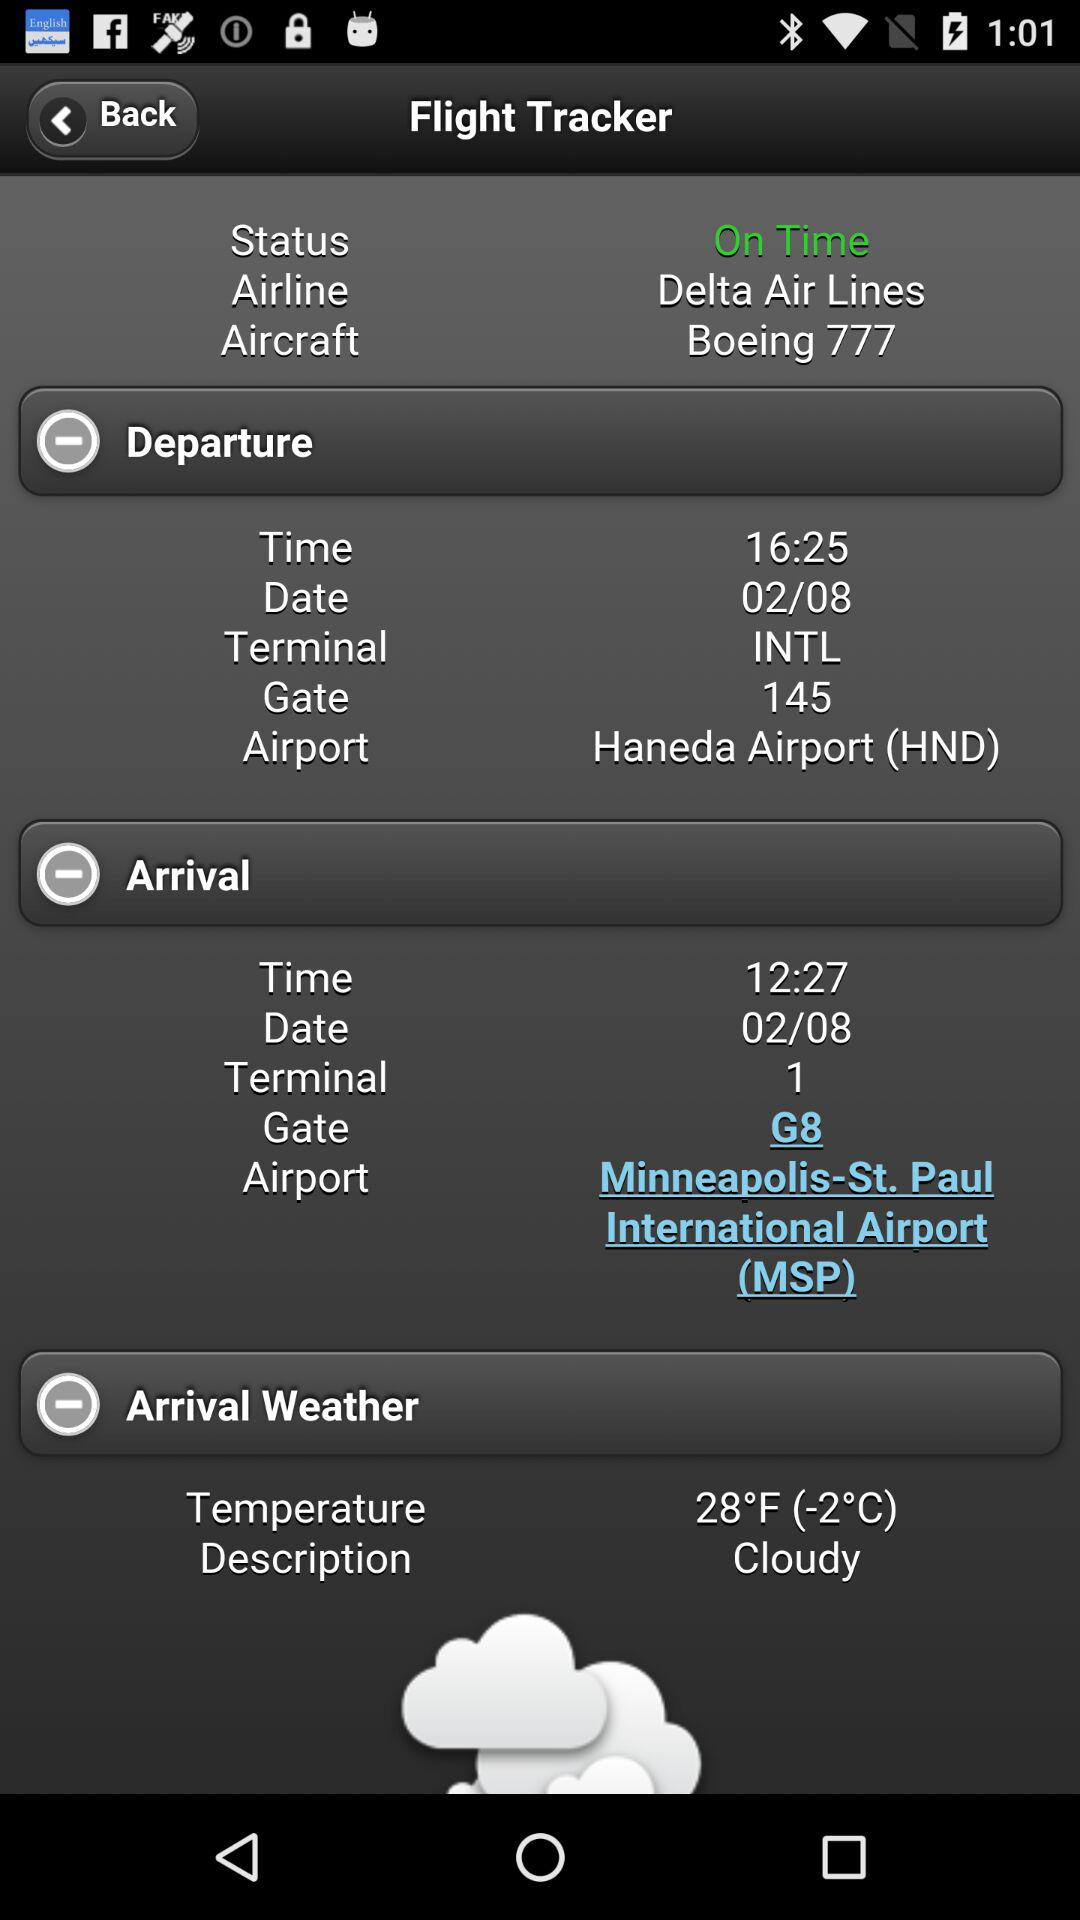What is the name of the airline? The name of the airline is "Delta Air Lines". 